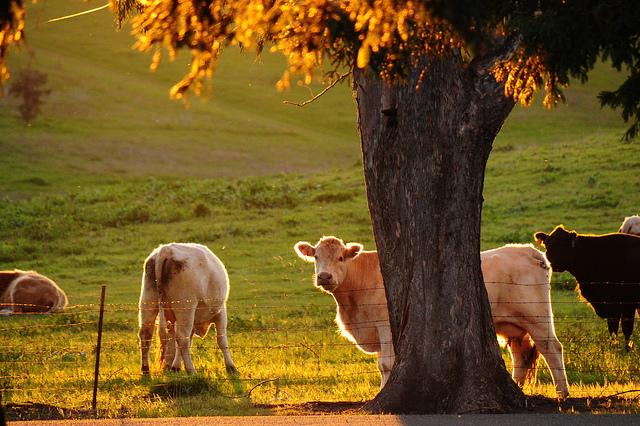What is one of the cows hiding behind? Please explain your reasoning. tree. The cow is behind a tree. 